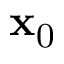Convert formula to latex. <formula><loc_0><loc_0><loc_500><loc_500>x _ { 0 }</formula> 